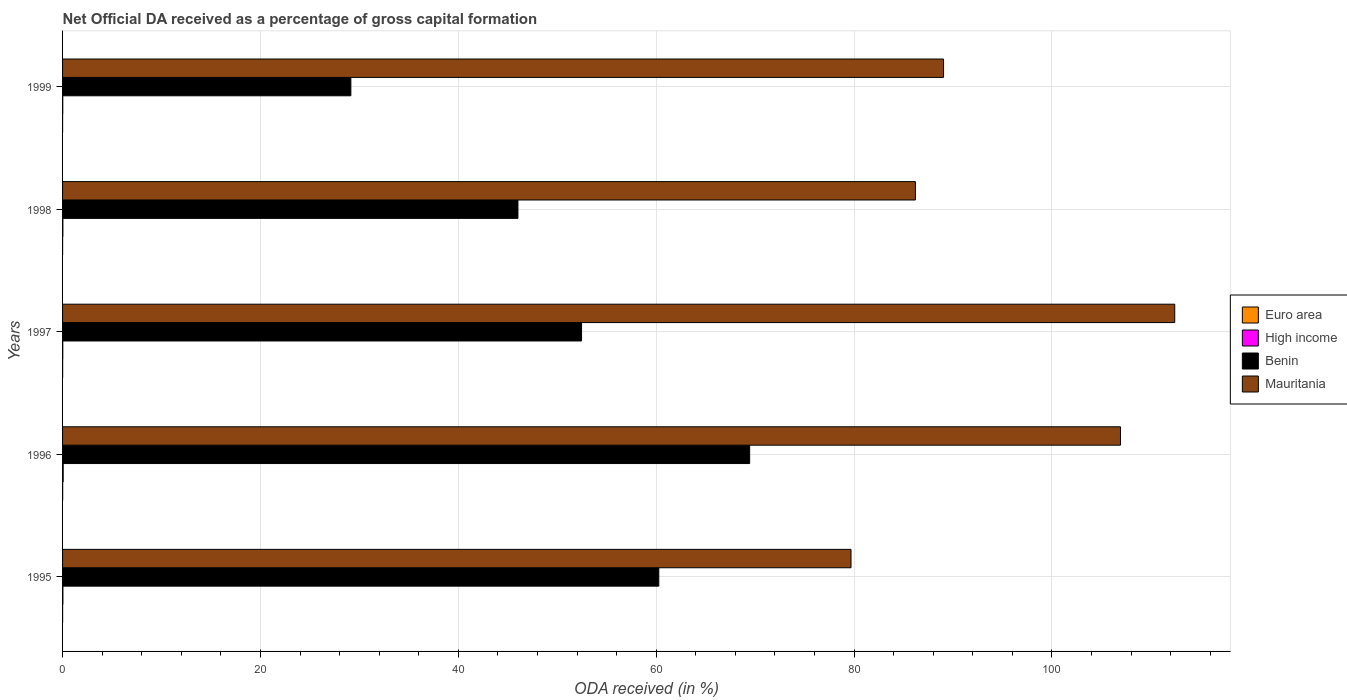How many groups of bars are there?
Make the answer very short. 5. Are the number of bars per tick equal to the number of legend labels?
Make the answer very short. Yes. Are the number of bars on each tick of the Y-axis equal?
Give a very brief answer. Yes. What is the label of the 1st group of bars from the top?
Your answer should be very brief. 1999. In how many cases, is the number of bars for a given year not equal to the number of legend labels?
Provide a short and direct response. 0. What is the net ODA received in High income in 1996?
Your answer should be very brief. 0.06. Across all years, what is the maximum net ODA received in Euro area?
Ensure brevity in your answer.  0.01. Across all years, what is the minimum net ODA received in Mauritania?
Provide a short and direct response. 79.69. What is the total net ODA received in Euro area in the graph?
Ensure brevity in your answer.  0.03. What is the difference between the net ODA received in Mauritania in 1997 and that in 1998?
Offer a very short reply. 26.21. What is the difference between the net ODA received in High income in 1998 and the net ODA received in Mauritania in 1997?
Your answer should be compact. -112.38. What is the average net ODA received in Mauritania per year?
Your answer should be compact. 94.85. In the year 1996, what is the difference between the net ODA received in High income and net ODA received in Mauritania?
Offer a terse response. -106.86. What is the ratio of the net ODA received in Euro area in 1997 to that in 1998?
Provide a short and direct response. 2.05. What is the difference between the highest and the second highest net ODA received in High income?
Provide a succinct answer. 0.03. What is the difference between the highest and the lowest net ODA received in Mauritania?
Ensure brevity in your answer.  32.72. In how many years, is the net ODA received in Mauritania greater than the average net ODA received in Mauritania taken over all years?
Keep it short and to the point. 2. What does the 2nd bar from the bottom in 1995 represents?
Provide a short and direct response. High income. Is it the case that in every year, the sum of the net ODA received in High income and net ODA received in Mauritania is greater than the net ODA received in Euro area?
Offer a terse response. Yes. How many bars are there?
Provide a succinct answer. 20. Are the values on the major ticks of X-axis written in scientific E-notation?
Your answer should be very brief. No. Does the graph contain any zero values?
Offer a very short reply. No. Where does the legend appear in the graph?
Ensure brevity in your answer.  Center right. How many legend labels are there?
Provide a short and direct response. 4. What is the title of the graph?
Make the answer very short. Net Official DA received as a percentage of gross capital formation. Does "Congo (Democratic)" appear as one of the legend labels in the graph?
Your response must be concise. No. What is the label or title of the X-axis?
Ensure brevity in your answer.  ODA received (in %). What is the label or title of the Y-axis?
Provide a short and direct response. Years. What is the ODA received (in %) of Euro area in 1995?
Provide a short and direct response. 0.01. What is the ODA received (in %) of High income in 1995?
Offer a very short reply. 0.03. What is the ODA received (in %) in Benin in 1995?
Your answer should be very brief. 60.26. What is the ODA received (in %) of Mauritania in 1995?
Give a very brief answer. 79.69. What is the ODA received (in %) in Euro area in 1996?
Give a very brief answer. 0.01. What is the ODA received (in %) of High income in 1996?
Your answer should be compact. 0.06. What is the ODA received (in %) in Benin in 1996?
Give a very brief answer. 69.45. What is the ODA received (in %) in Mauritania in 1996?
Ensure brevity in your answer.  106.93. What is the ODA received (in %) in Euro area in 1997?
Provide a succinct answer. 0.01. What is the ODA received (in %) of High income in 1997?
Provide a succinct answer. 0.02. What is the ODA received (in %) in Benin in 1997?
Your answer should be very brief. 52.45. What is the ODA received (in %) of Mauritania in 1997?
Make the answer very short. 112.41. What is the ODA received (in %) of Euro area in 1998?
Your answer should be compact. 0. What is the ODA received (in %) of High income in 1998?
Your answer should be compact. 0.03. What is the ODA received (in %) of Benin in 1998?
Your answer should be compact. 46.03. What is the ODA received (in %) of Mauritania in 1998?
Offer a terse response. 86.2. What is the ODA received (in %) of Euro area in 1999?
Give a very brief answer. 0. What is the ODA received (in %) in High income in 1999?
Your answer should be very brief. 0.02. What is the ODA received (in %) in Benin in 1999?
Provide a short and direct response. 29.14. What is the ODA received (in %) in Mauritania in 1999?
Offer a very short reply. 89.04. Across all years, what is the maximum ODA received (in %) of Euro area?
Give a very brief answer. 0.01. Across all years, what is the maximum ODA received (in %) in High income?
Give a very brief answer. 0.06. Across all years, what is the maximum ODA received (in %) in Benin?
Keep it short and to the point. 69.45. Across all years, what is the maximum ODA received (in %) of Mauritania?
Offer a terse response. 112.41. Across all years, what is the minimum ODA received (in %) of Euro area?
Your answer should be compact. 0. Across all years, what is the minimum ODA received (in %) of High income?
Offer a very short reply. 0.02. Across all years, what is the minimum ODA received (in %) of Benin?
Give a very brief answer. 29.14. Across all years, what is the minimum ODA received (in %) of Mauritania?
Make the answer very short. 79.69. What is the total ODA received (in %) of Euro area in the graph?
Offer a very short reply. 0.03. What is the total ODA received (in %) of High income in the graph?
Ensure brevity in your answer.  0.17. What is the total ODA received (in %) of Benin in the graph?
Make the answer very short. 257.33. What is the total ODA received (in %) of Mauritania in the graph?
Your answer should be very brief. 474.27. What is the difference between the ODA received (in %) in Euro area in 1995 and that in 1996?
Provide a short and direct response. -0.01. What is the difference between the ODA received (in %) in High income in 1995 and that in 1996?
Offer a very short reply. -0.03. What is the difference between the ODA received (in %) of Benin in 1995 and that in 1996?
Offer a very short reply. -9.18. What is the difference between the ODA received (in %) of Mauritania in 1995 and that in 1996?
Your answer should be very brief. -27.24. What is the difference between the ODA received (in %) of Euro area in 1995 and that in 1997?
Ensure brevity in your answer.  -0. What is the difference between the ODA received (in %) in High income in 1995 and that in 1997?
Provide a succinct answer. 0.01. What is the difference between the ODA received (in %) in Benin in 1995 and that in 1997?
Ensure brevity in your answer.  7.81. What is the difference between the ODA received (in %) of Mauritania in 1995 and that in 1997?
Keep it short and to the point. -32.72. What is the difference between the ODA received (in %) in Euro area in 1995 and that in 1998?
Keep it short and to the point. 0. What is the difference between the ODA received (in %) in High income in 1995 and that in 1998?
Provide a succinct answer. 0. What is the difference between the ODA received (in %) of Benin in 1995 and that in 1998?
Your answer should be very brief. 14.24. What is the difference between the ODA received (in %) in Mauritania in 1995 and that in 1998?
Offer a very short reply. -6.51. What is the difference between the ODA received (in %) of Euro area in 1995 and that in 1999?
Ensure brevity in your answer.  0. What is the difference between the ODA received (in %) in High income in 1995 and that in 1999?
Your answer should be very brief. 0.02. What is the difference between the ODA received (in %) of Benin in 1995 and that in 1999?
Make the answer very short. 31.13. What is the difference between the ODA received (in %) of Mauritania in 1995 and that in 1999?
Offer a terse response. -9.35. What is the difference between the ODA received (in %) of Euro area in 1996 and that in 1997?
Offer a terse response. 0. What is the difference between the ODA received (in %) in High income in 1996 and that in 1997?
Provide a short and direct response. 0.04. What is the difference between the ODA received (in %) in Benin in 1996 and that in 1997?
Your response must be concise. 16.99. What is the difference between the ODA received (in %) of Mauritania in 1996 and that in 1997?
Your answer should be compact. -5.48. What is the difference between the ODA received (in %) of Euro area in 1996 and that in 1998?
Provide a succinct answer. 0.01. What is the difference between the ODA received (in %) in High income in 1996 and that in 1998?
Ensure brevity in your answer.  0.03. What is the difference between the ODA received (in %) of Benin in 1996 and that in 1998?
Ensure brevity in your answer.  23.42. What is the difference between the ODA received (in %) of Mauritania in 1996 and that in 1998?
Offer a terse response. 20.73. What is the difference between the ODA received (in %) in Euro area in 1996 and that in 1999?
Offer a terse response. 0.01. What is the difference between the ODA received (in %) of High income in 1996 and that in 1999?
Provide a succinct answer. 0.04. What is the difference between the ODA received (in %) of Benin in 1996 and that in 1999?
Keep it short and to the point. 40.31. What is the difference between the ODA received (in %) of Mauritania in 1996 and that in 1999?
Offer a very short reply. 17.88. What is the difference between the ODA received (in %) of Euro area in 1997 and that in 1998?
Provide a short and direct response. 0. What is the difference between the ODA received (in %) of High income in 1997 and that in 1998?
Your response must be concise. -0.01. What is the difference between the ODA received (in %) of Benin in 1997 and that in 1998?
Ensure brevity in your answer.  6.43. What is the difference between the ODA received (in %) in Mauritania in 1997 and that in 1998?
Make the answer very short. 26.21. What is the difference between the ODA received (in %) of Euro area in 1997 and that in 1999?
Ensure brevity in your answer.  0. What is the difference between the ODA received (in %) in High income in 1997 and that in 1999?
Your answer should be compact. 0. What is the difference between the ODA received (in %) in Benin in 1997 and that in 1999?
Your answer should be very brief. 23.32. What is the difference between the ODA received (in %) in Mauritania in 1997 and that in 1999?
Keep it short and to the point. 23.37. What is the difference between the ODA received (in %) in Euro area in 1998 and that in 1999?
Your answer should be very brief. 0. What is the difference between the ODA received (in %) in High income in 1998 and that in 1999?
Ensure brevity in your answer.  0.01. What is the difference between the ODA received (in %) in Benin in 1998 and that in 1999?
Provide a succinct answer. 16.89. What is the difference between the ODA received (in %) of Mauritania in 1998 and that in 1999?
Keep it short and to the point. -2.84. What is the difference between the ODA received (in %) in Euro area in 1995 and the ODA received (in %) in High income in 1996?
Your answer should be very brief. -0.06. What is the difference between the ODA received (in %) in Euro area in 1995 and the ODA received (in %) in Benin in 1996?
Provide a short and direct response. -69.44. What is the difference between the ODA received (in %) in Euro area in 1995 and the ODA received (in %) in Mauritania in 1996?
Your response must be concise. -106.92. What is the difference between the ODA received (in %) of High income in 1995 and the ODA received (in %) of Benin in 1996?
Provide a short and direct response. -69.41. What is the difference between the ODA received (in %) in High income in 1995 and the ODA received (in %) in Mauritania in 1996?
Your answer should be compact. -106.89. What is the difference between the ODA received (in %) of Benin in 1995 and the ODA received (in %) of Mauritania in 1996?
Offer a very short reply. -46.66. What is the difference between the ODA received (in %) of Euro area in 1995 and the ODA received (in %) of High income in 1997?
Offer a very short reply. -0.02. What is the difference between the ODA received (in %) of Euro area in 1995 and the ODA received (in %) of Benin in 1997?
Provide a short and direct response. -52.45. What is the difference between the ODA received (in %) in Euro area in 1995 and the ODA received (in %) in Mauritania in 1997?
Your answer should be compact. -112.4. What is the difference between the ODA received (in %) in High income in 1995 and the ODA received (in %) in Benin in 1997?
Provide a succinct answer. -52.42. What is the difference between the ODA received (in %) in High income in 1995 and the ODA received (in %) in Mauritania in 1997?
Give a very brief answer. -112.38. What is the difference between the ODA received (in %) of Benin in 1995 and the ODA received (in %) of Mauritania in 1997?
Give a very brief answer. -52.15. What is the difference between the ODA received (in %) of Euro area in 1995 and the ODA received (in %) of High income in 1998?
Keep it short and to the point. -0.03. What is the difference between the ODA received (in %) in Euro area in 1995 and the ODA received (in %) in Benin in 1998?
Provide a succinct answer. -46.02. What is the difference between the ODA received (in %) of Euro area in 1995 and the ODA received (in %) of Mauritania in 1998?
Give a very brief answer. -86.19. What is the difference between the ODA received (in %) of High income in 1995 and the ODA received (in %) of Benin in 1998?
Offer a terse response. -45.99. What is the difference between the ODA received (in %) of High income in 1995 and the ODA received (in %) of Mauritania in 1998?
Provide a short and direct response. -86.17. What is the difference between the ODA received (in %) of Benin in 1995 and the ODA received (in %) of Mauritania in 1998?
Your answer should be compact. -25.94. What is the difference between the ODA received (in %) of Euro area in 1995 and the ODA received (in %) of High income in 1999?
Your answer should be very brief. -0.01. What is the difference between the ODA received (in %) in Euro area in 1995 and the ODA received (in %) in Benin in 1999?
Give a very brief answer. -29.13. What is the difference between the ODA received (in %) in Euro area in 1995 and the ODA received (in %) in Mauritania in 1999?
Offer a terse response. -89.04. What is the difference between the ODA received (in %) in High income in 1995 and the ODA received (in %) in Benin in 1999?
Offer a terse response. -29.1. What is the difference between the ODA received (in %) in High income in 1995 and the ODA received (in %) in Mauritania in 1999?
Your response must be concise. -89.01. What is the difference between the ODA received (in %) in Benin in 1995 and the ODA received (in %) in Mauritania in 1999?
Keep it short and to the point. -28.78. What is the difference between the ODA received (in %) in Euro area in 1996 and the ODA received (in %) in High income in 1997?
Your answer should be very brief. -0.01. What is the difference between the ODA received (in %) in Euro area in 1996 and the ODA received (in %) in Benin in 1997?
Give a very brief answer. -52.44. What is the difference between the ODA received (in %) in Euro area in 1996 and the ODA received (in %) in Mauritania in 1997?
Your answer should be compact. -112.4. What is the difference between the ODA received (in %) of High income in 1996 and the ODA received (in %) of Benin in 1997?
Offer a terse response. -52.39. What is the difference between the ODA received (in %) in High income in 1996 and the ODA received (in %) in Mauritania in 1997?
Your answer should be compact. -112.35. What is the difference between the ODA received (in %) of Benin in 1996 and the ODA received (in %) of Mauritania in 1997?
Your response must be concise. -42.96. What is the difference between the ODA received (in %) in Euro area in 1996 and the ODA received (in %) in High income in 1998?
Provide a succinct answer. -0.02. What is the difference between the ODA received (in %) of Euro area in 1996 and the ODA received (in %) of Benin in 1998?
Offer a very short reply. -46.02. What is the difference between the ODA received (in %) in Euro area in 1996 and the ODA received (in %) in Mauritania in 1998?
Keep it short and to the point. -86.19. What is the difference between the ODA received (in %) in High income in 1996 and the ODA received (in %) in Benin in 1998?
Provide a succinct answer. -45.96. What is the difference between the ODA received (in %) of High income in 1996 and the ODA received (in %) of Mauritania in 1998?
Ensure brevity in your answer.  -86.14. What is the difference between the ODA received (in %) in Benin in 1996 and the ODA received (in %) in Mauritania in 1998?
Offer a terse response. -16.75. What is the difference between the ODA received (in %) in Euro area in 1996 and the ODA received (in %) in High income in 1999?
Offer a terse response. -0.01. What is the difference between the ODA received (in %) of Euro area in 1996 and the ODA received (in %) of Benin in 1999?
Provide a succinct answer. -29.13. What is the difference between the ODA received (in %) of Euro area in 1996 and the ODA received (in %) of Mauritania in 1999?
Make the answer very short. -89.03. What is the difference between the ODA received (in %) of High income in 1996 and the ODA received (in %) of Benin in 1999?
Your answer should be very brief. -29.08. What is the difference between the ODA received (in %) of High income in 1996 and the ODA received (in %) of Mauritania in 1999?
Make the answer very short. -88.98. What is the difference between the ODA received (in %) of Benin in 1996 and the ODA received (in %) of Mauritania in 1999?
Make the answer very short. -19.6. What is the difference between the ODA received (in %) of Euro area in 1997 and the ODA received (in %) of High income in 1998?
Your answer should be very brief. -0.02. What is the difference between the ODA received (in %) in Euro area in 1997 and the ODA received (in %) in Benin in 1998?
Make the answer very short. -46.02. What is the difference between the ODA received (in %) of Euro area in 1997 and the ODA received (in %) of Mauritania in 1998?
Provide a short and direct response. -86.19. What is the difference between the ODA received (in %) of High income in 1997 and the ODA received (in %) of Benin in 1998?
Offer a very short reply. -46. What is the difference between the ODA received (in %) in High income in 1997 and the ODA received (in %) in Mauritania in 1998?
Offer a very short reply. -86.18. What is the difference between the ODA received (in %) of Benin in 1997 and the ODA received (in %) of Mauritania in 1998?
Give a very brief answer. -33.74. What is the difference between the ODA received (in %) in Euro area in 1997 and the ODA received (in %) in High income in 1999?
Offer a very short reply. -0.01. What is the difference between the ODA received (in %) of Euro area in 1997 and the ODA received (in %) of Benin in 1999?
Your answer should be very brief. -29.13. What is the difference between the ODA received (in %) of Euro area in 1997 and the ODA received (in %) of Mauritania in 1999?
Provide a short and direct response. -89.04. What is the difference between the ODA received (in %) in High income in 1997 and the ODA received (in %) in Benin in 1999?
Make the answer very short. -29.12. What is the difference between the ODA received (in %) in High income in 1997 and the ODA received (in %) in Mauritania in 1999?
Your answer should be compact. -89.02. What is the difference between the ODA received (in %) of Benin in 1997 and the ODA received (in %) of Mauritania in 1999?
Offer a terse response. -36.59. What is the difference between the ODA received (in %) in Euro area in 1998 and the ODA received (in %) in High income in 1999?
Offer a terse response. -0.01. What is the difference between the ODA received (in %) of Euro area in 1998 and the ODA received (in %) of Benin in 1999?
Offer a very short reply. -29.13. What is the difference between the ODA received (in %) of Euro area in 1998 and the ODA received (in %) of Mauritania in 1999?
Provide a succinct answer. -89.04. What is the difference between the ODA received (in %) in High income in 1998 and the ODA received (in %) in Benin in 1999?
Offer a terse response. -29.11. What is the difference between the ODA received (in %) in High income in 1998 and the ODA received (in %) in Mauritania in 1999?
Offer a very short reply. -89.01. What is the difference between the ODA received (in %) in Benin in 1998 and the ODA received (in %) in Mauritania in 1999?
Your answer should be very brief. -43.02. What is the average ODA received (in %) of Euro area per year?
Your response must be concise. 0.01. What is the average ODA received (in %) of High income per year?
Ensure brevity in your answer.  0.03. What is the average ODA received (in %) of Benin per year?
Ensure brevity in your answer.  51.47. What is the average ODA received (in %) in Mauritania per year?
Provide a succinct answer. 94.85. In the year 1995, what is the difference between the ODA received (in %) of Euro area and ODA received (in %) of High income?
Ensure brevity in your answer.  -0.03. In the year 1995, what is the difference between the ODA received (in %) of Euro area and ODA received (in %) of Benin?
Your answer should be very brief. -60.26. In the year 1995, what is the difference between the ODA received (in %) in Euro area and ODA received (in %) in Mauritania?
Offer a terse response. -79.69. In the year 1995, what is the difference between the ODA received (in %) of High income and ODA received (in %) of Benin?
Your answer should be compact. -60.23. In the year 1995, what is the difference between the ODA received (in %) of High income and ODA received (in %) of Mauritania?
Keep it short and to the point. -79.66. In the year 1995, what is the difference between the ODA received (in %) of Benin and ODA received (in %) of Mauritania?
Keep it short and to the point. -19.43. In the year 1996, what is the difference between the ODA received (in %) in Euro area and ODA received (in %) in High income?
Provide a succinct answer. -0.05. In the year 1996, what is the difference between the ODA received (in %) of Euro area and ODA received (in %) of Benin?
Your response must be concise. -69.44. In the year 1996, what is the difference between the ODA received (in %) in Euro area and ODA received (in %) in Mauritania?
Give a very brief answer. -106.92. In the year 1996, what is the difference between the ODA received (in %) in High income and ODA received (in %) in Benin?
Provide a short and direct response. -69.38. In the year 1996, what is the difference between the ODA received (in %) in High income and ODA received (in %) in Mauritania?
Offer a terse response. -106.86. In the year 1996, what is the difference between the ODA received (in %) of Benin and ODA received (in %) of Mauritania?
Provide a succinct answer. -37.48. In the year 1997, what is the difference between the ODA received (in %) in Euro area and ODA received (in %) in High income?
Offer a terse response. -0.01. In the year 1997, what is the difference between the ODA received (in %) of Euro area and ODA received (in %) of Benin?
Provide a succinct answer. -52.45. In the year 1997, what is the difference between the ODA received (in %) of Euro area and ODA received (in %) of Mauritania?
Provide a succinct answer. -112.4. In the year 1997, what is the difference between the ODA received (in %) of High income and ODA received (in %) of Benin?
Offer a terse response. -52.43. In the year 1997, what is the difference between the ODA received (in %) in High income and ODA received (in %) in Mauritania?
Ensure brevity in your answer.  -112.39. In the year 1997, what is the difference between the ODA received (in %) in Benin and ODA received (in %) in Mauritania?
Ensure brevity in your answer.  -59.96. In the year 1998, what is the difference between the ODA received (in %) in Euro area and ODA received (in %) in High income?
Your answer should be very brief. -0.03. In the year 1998, what is the difference between the ODA received (in %) of Euro area and ODA received (in %) of Benin?
Your answer should be compact. -46.02. In the year 1998, what is the difference between the ODA received (in %) in Euro area and ODA received (in %) in Mauritania?
Make the answer very short. -86.2. In the year 1998, what is the difference between the ODA received (in %) in High income and ODA received (in %) in Benin?
Your answer should be very brief. -45.99. In the year 1998, what is the difference between the ODA received (in %) of High income and ODA received (in %) of Mauritania?
Make the answer very short. -86.17. In the year 1998, what is the difference between the ODA received (in %) of Benin and ODA received (in %) of Mauritania?
Keep it short and to the point. -40.17. In the year 1999, what is the difference between the ODA received (in %) of Euro area and ODA received (in %) of High income?
Your answer should be very brief. -0.01. In the year 1999, what is the difference between the ODA received (in %) in Euro area and ODA received (in %) in Benin?
Keep it short and to the point. -29.13. In the year 1999, what is the difference between the ODA received (in %) in Euro area and ODA received (in %) in Mauritania?
Ensure brevity in your answer.  -89.04. In the year 1999, what is the difference between the ODA received (in %) of High income and ODA received (in %) of Benin?
Ensure brevity in your answer.  -29.12. In the year 1999, what is the difference between the ODA received (in %) of High income and ODA received (in %) of Mauritania?
Give a very brief answer. -89.03. In the year 1999, what is the difference between the ODA received (in %) in Benin and ODA received (in %) in Mauritania?
Ensure brevity in your answer.  -59.91. What is the ratio of the ODA received (in %) of Euro area in 1995 to that in 1996?
Provide a succinct answer. 0.46. What is the ratio of the ODA received (in %) in High income in 1995 to that in 1996?
Provide a succinct answer. 0.54. What is the ratio of the ODA received (in %) in Benin in 1995 to that in 1996?
Give a very brief answer. 0.87. What is the ratio of the ODA received (in %) of Mauritania in 1995 to that in 1996?
Your response must be concise. 0.75. What is the ratio of the ODA received (in %) of Euro area in 1995 to that in 1997?
Provide a short and direct response. 0.63. What is the ratio of the ODA received (in %) in High income in 1995 to that in 1997?
Offer a terse response. 1.55. What is the ratio of the ODA received (in %) in Benin in 1995 to that in 1997?
Ensure brevity in your answer.  1.15. What is the ratio of the ODA received (in %) in Mauritania in 1995 to that in 1997?
Provide a succinct answer. 0.71. What is the ratio of the ODA received (in %) in Euro area in 1995 to that in 1998?
Provide a short and direct response. 1.3. What is the ratio of the ODA received (in %) of High income in 1995 to that in 1998?
Give a very brief answer. 1.09. What is the ratio of the ODA received (in %) in Benin in 1995 to that in 1998?
Make the answer very short. 1.31. What is the ratio of the ODA received (in %) of Mauritania in 1995 to that in 1998?
Offer a terse response. 0.92. What is the ratio of the ODA received (in %) of Euro area in 1995 to that in 1999?
Provide a succinct answer. 1.45. What is the ratio of the ODA received (in %) of High income in 1995 to that in 1999?
Your answer should be very brief. 1.89. What is the ratio of the ODA received (in %) of Benin in 1995 to that in 1999?
Give a very brief answer. 2.07. What is the ratio of the ODA received (in %) of Mauritania in 1995 to that in 1999?
Ensure brevity in your answer.  0.9. What is the ratio of the ODA received (in %) in Euro area in 1996 to that in 1997?
Provide a succinct answer. 1.37. What is the ratio of the ODA received (in %) in High income in 1996 to that in 1997?
Your response must be concise. 2.87. What is the ratio of the ODA received (in %) in Benin in 1996 to that in 1997?
Offer a very short reply. 1.32. What is the ratio of the ODA received (in %) in Mauritania in 1996 to that in 1997?
Provide a succinct answer. 0.95. What is the ratio of the ODA received (in %) in Euro area in 1996 to that in 1998?
Your response must be concise. 2.81. What is the ratio of the ODA received (in %) of High income in 1996 to that in 1998?
Make the answer very short. 2.02. What is the ratio of the ODA received (in %) in Benin in 1996 to that in 1998?
Your answer should be very brief. 1.51. What is the ratio of the ODA received (in %) of Mauritania in 1996 to that in 1998?
Make the answer very short. 1.24. What is the ratio of the ODA received (in %) in Euro area in 1996 to that in 1999?
Your answer should be very brief. 3.13. What is the ratio of the ODA received (in %) of High income in 1996 to that in 1999?
Keep it short and to the point. 3.49. What is the ratio of the ODA received (in %) of Benin in 1996 to that in 1999?
Offer a terse response. 2.38. What is the ratio of the ODA received (in %) in Mauritania in 1996 to that in 1999?
Ensure brevity in your answer.  1.2. What is the ratio of the ODA received (in %) of Euro area in 1997 to that in 1998?
Make the answer very short. 2.05. What is the ratio of the ODA received (in %) in High income in 1997 to that in 1998?
Provide a short and direct response. 0.7. What is the ratio of the ODA received (in %) of Benin in 1997 to that in 1998?
Provide a succinct answer. 1.14. What is the ratio of the ODA received (in %) of Mauritania in 1997 to that in 1998?
Your answer should be compact. 1.3. What is the ratio of the ODA received (in %) in Euro area in 1997 to that in 1999?
Provide a short and direct response. 2.29. What is the ratio of the ODA received (in %) of High income in 1997 to that in 1999?
Make the answer very short. 1.22. What is the ratio of the ODA received (in %) in Benin in 1997 to that in 1999?
Give a very brief answer. 1.8. What is the ratio of the ODA received (in %) of Mauritania in 1997 to that in 1999?
Provide a succinct answer. 1.26. What is the ratio of the ODA received (in %) of Euro area in 1998 to that in 1999?
Keep it short and to the point. 1.11. What is the ratio of the ODA received (in %) of High income in 1998 to that in 1999?
Your response must be concise. 1.73. What is the ratio of the ODA received (in %) of Benin in 1998 to that in 1999?
Offer a terse response. 1.58. What is the ratio of the ODA received (in %) of Mauritania in 1998 to that in 1999?
Offer a terse response. 0.97. What is the difference between the highest and the second highest ODA received (in %) of Euro area?
Your answer should be very brief. 0. What is the difference between the highest and the second highest ODA received (in %) in High income?
Offer a very short reply. 0.03. What is the difference between the highest and the second highest ODA received (in %) of Benin?
Offer a very short reply. 9.18. What is the difference between the highest and the second highest ODA received (in %) in Mauritania?
Offer a terse response. 5.48. What is the difference between the highest and the lowest ODA received (in %) in Euro area?
Offer a very short reply. 0.01. What is the difference between the highest and the lowest ODA received (in %) of High income?
Your answer should be very brief. 0.04. What is the difference between the highest and the lowest ODA received (in %) of Benin?
Keep it short and to the point. 40.31. What is the difference between the highest and the lowest ODA received (in %) of Mauritania?
Ensure brevity in your answer.  32.72. 